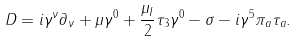<formula> <loc_0><loc_0><loc_500><loc_500>D = i \gamma ^ { \nu } \partial _ { \nu } + \mu \gamma ^ { 0 } + \frac { \mu _ { I } } { 2 } \tau _ { 3 } \gamma ^ { 0 } - \sigma - i \gamma ^ { 5 } \pi _ { a } \tau _ { a } .</formula> 